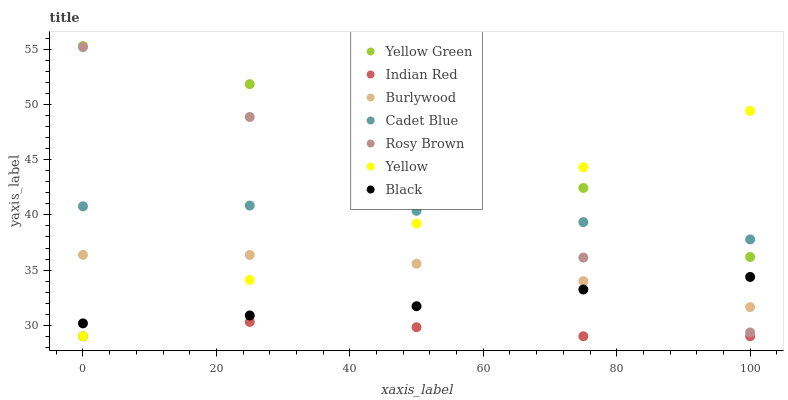Does Indian Red have the minimum area under the curve?
Answer yes or no. Yes. Does Yellow Green have the maximum area under the curve?
Answer yes or no. Yes. Does Burlywood have the minimum area under the curve?
Answer yes or no. No. Does Burlywood have the maximum area under the curve?
Answer yes or no. No. Is Yellow the smoothest?
Answer yes or no. Yes. Is Rosy Brown the roughest?
Answer yes or no. Yes. Is Yellow Green the smoothest?
Answer yes or no. No. Is Yellow Green the roughest?
Answer yes or no. No. Does Yellow have the lowest value?
Answer yes or no. Yes. Does Yellow Green have the lowest value?
Answer yes or no. No. Does Yellow Green have the highest value?
Answer yes or no. Yes. Does Burlywood have the highest value?
Answer yes or no. No. Is Indian Red less than Yellow Green?
Answer yes or no. Yes. Is Yellow Green greater than Black?
Answer yes or no. Yes. Does Yellow intersect Yellow Green?
Answer yes or no. Yes. Is Yellow less than Yellow Green?
Answer yes or no. No. Is Yellow greater than Yellow Green?
Answer yes or no. No. Does Indian Red intersect Yellow Green?
Answer yes or no. No. 